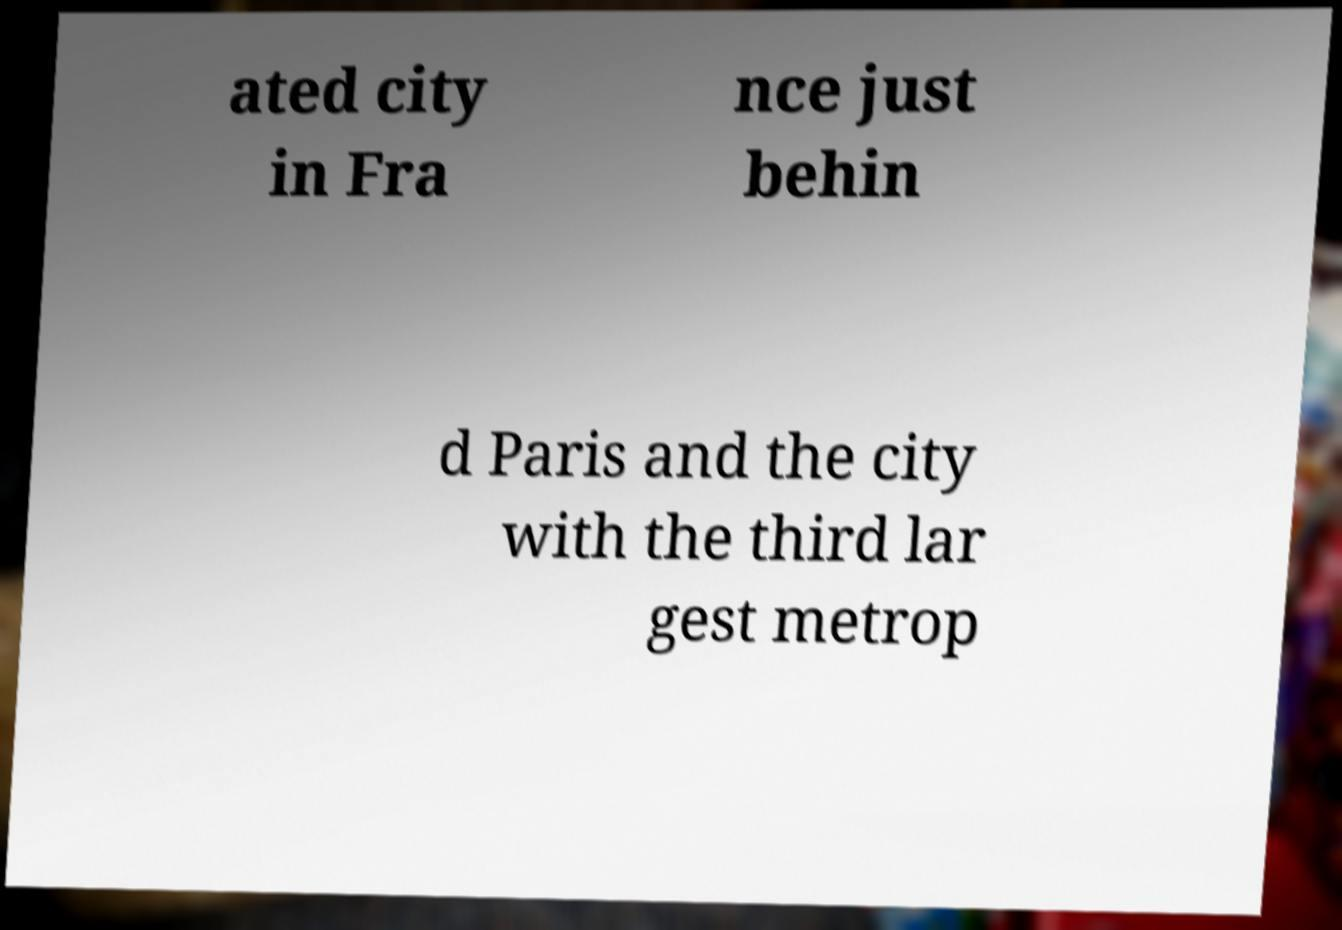What messages or text are displayed in this image? I need them in a readable, typed format. ated city in Fra nce just behin d Paris and the city with the third lar gest metrop 